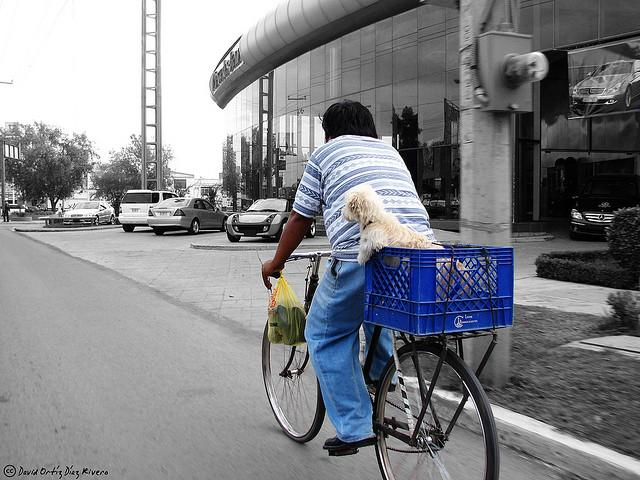Why is there a car poster on the building?

Choices:
A) window cover
B) advertisement
C) decoration
D) missing poster advertisement 